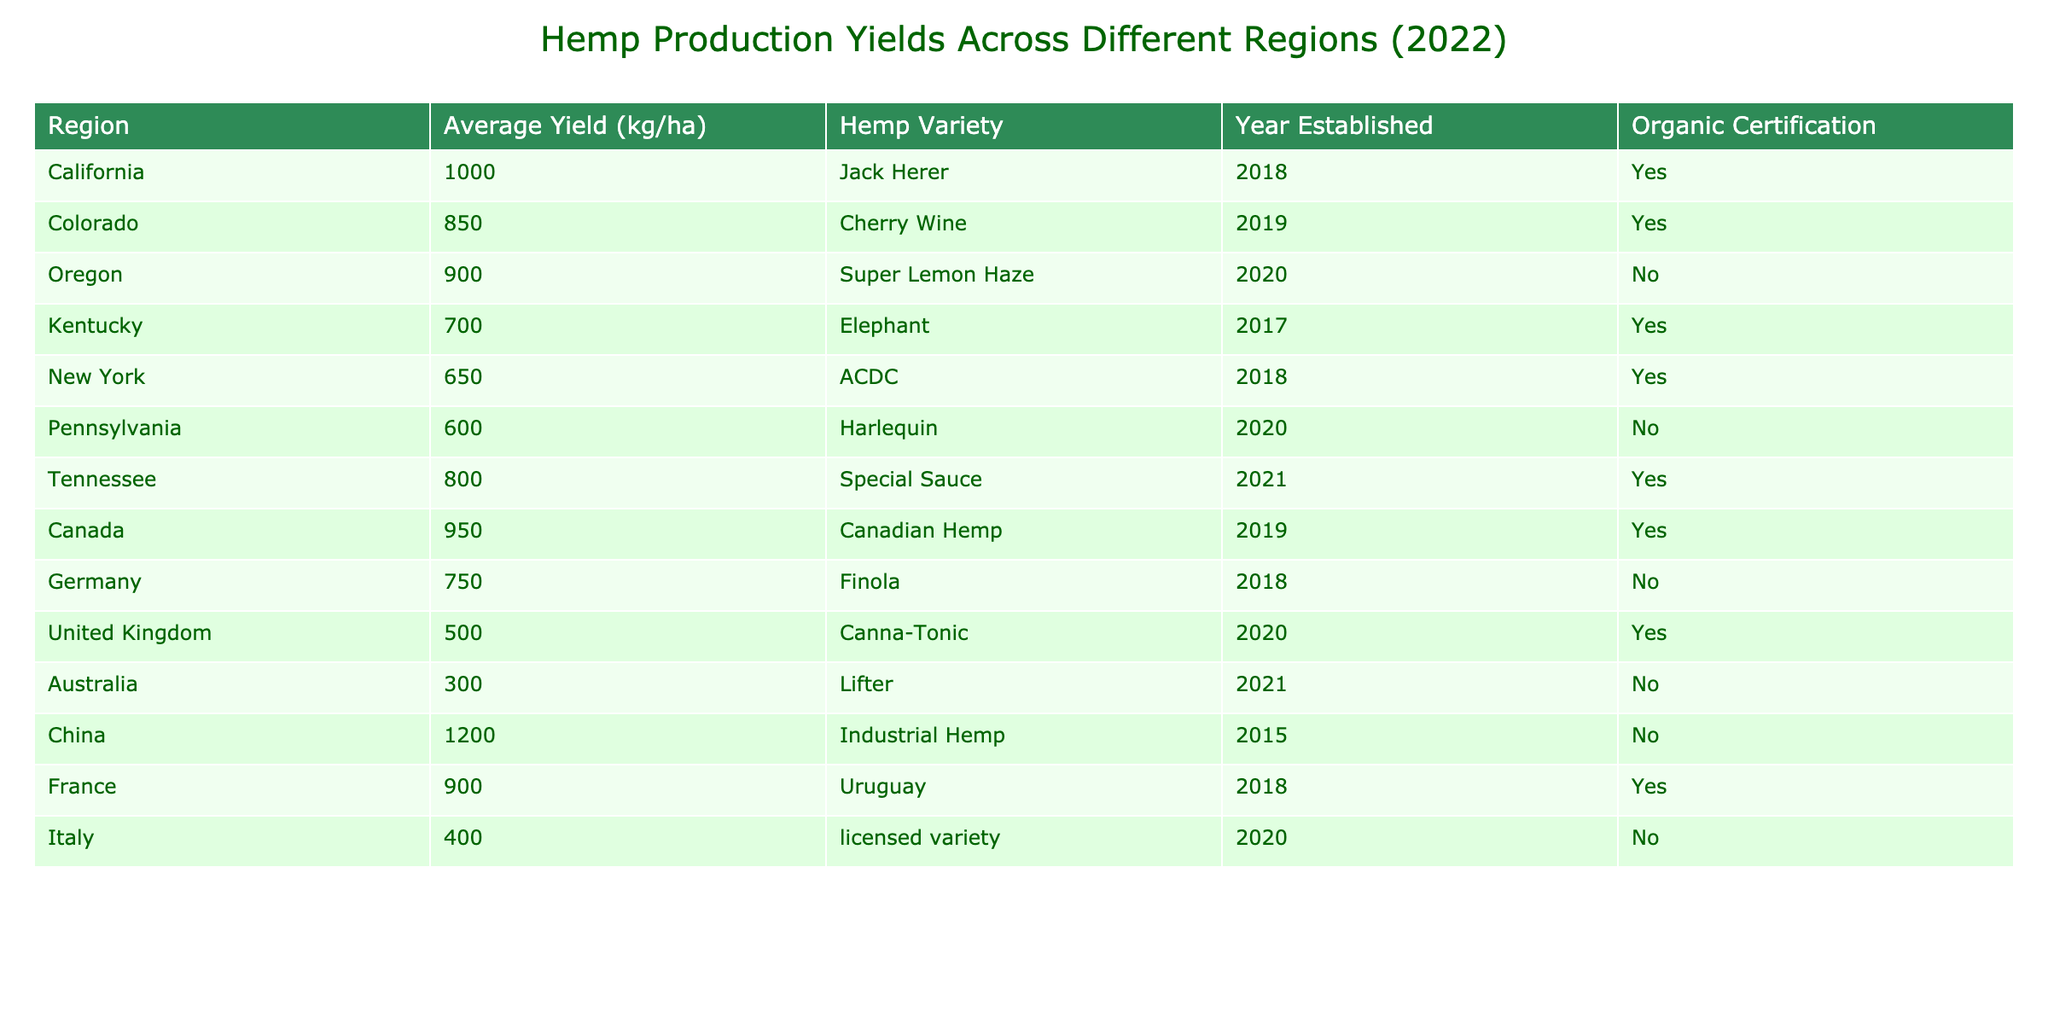What is the highest average yield among the regions listed? By examining the "Average Yield (kg/ha)" column, the highest value is 1200, found in the "China" row.
Answer: 1200 Which region has the lowest average yield? Looking at the "Average Yield (kg/ha)" column, the lowest value is 300, corresponding to the "Australia" entry.
Answer: 300 How many regions have an organic certification? The "Organic Certification" column has a "Yes" value for 6 out of the 12 listed regions.
Answer: 6 What is the average yield of regions with organic certification? The average yield is calculated by summing the values for regions with "Yes" in the Organic Certification column (1000 + 850 + 700 + 650 + 800 + 950 + 900 = 4950) and dividing by 6, which results in 4950/6 = 825.
Answer: 825 Which region has the oldest establishment year, and what is its yield? Scanning the "Year Established" column, "China" is listed as established in 2015 and has an average yield of 1200 kg/ha.
Answer: China, 1200 Are there any regions with an average yield over 900 kg/ha that do not have organic certification? Examining the table, "Oregon" with a yield of 900 kg/ha does not have certification, but all other regions above 900 do have organic certification. Thus, the answer is no.
Answer: No What is the difference in average yield between the region with the highest yield and the lowest? The highest average yield is 1200 (China) and the lowest is 300 (Australia). The difference is 1200 - 300 = 900 kg/ha.
Answer: 900 Which hemp variety is associated with the second highest average yield? The second highest yield is 950 kg/ha for "Canadian Hemp," which is grown in Canada as per the "Hemp Variety" column.
Answer: Canadian Hemp What fraction of the total regions listed are established after 2018? There are 5 regions established in 2019 or later (Colorado, Oregon, Tennessee, Canada, and Australia) out of 12 total regions, leading to the fraction 5/12.
Answer: 5/12 List the regions that do not have organic certification. The regions without organic certification are Oregon, Pennsylvania, Germany, Australia, and Italy. The count is 5 regions.
Answer: 5 regions 